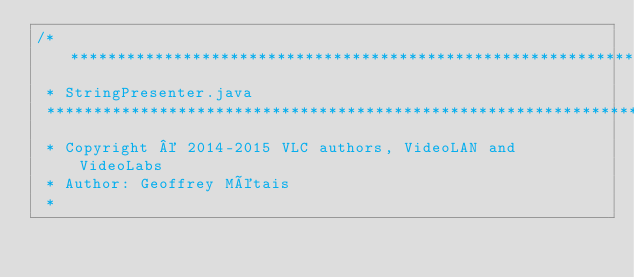Convert code to text. <code><loc_0><loc_0><loc_500><loc_500><_Java_>/*****************************************************************************
 * StringPresenter.java
 *****************************************************************************
 * Copyright © 2014-2015 VLC authors, VideoLAN and VideoLabs
 * Author: Geoffrey Métais
 *</code> 